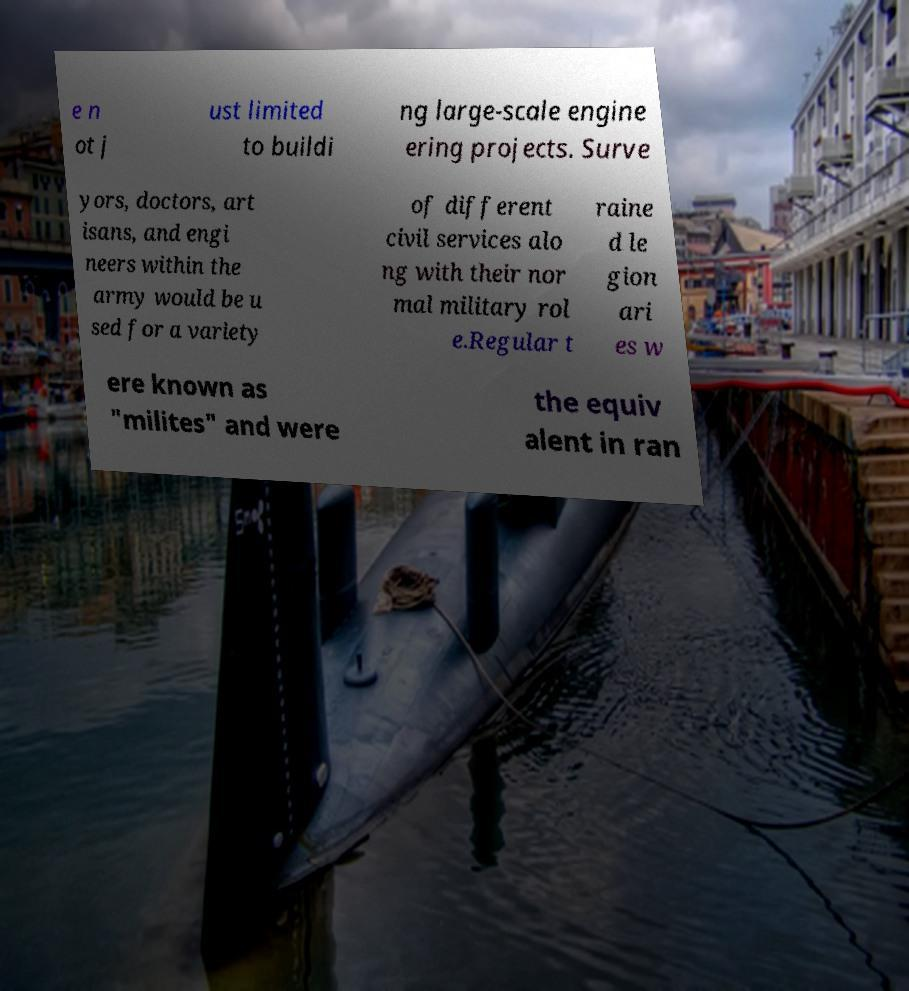For documentation purposes, I need the text within this image transcribed. Could you provide that? e n ot j ust limited to buildi ng large-scale engine ering projects. Surve yors, doctors, art isans, and engi neers within the army would be u sed for a variety of different civil services alo ng with their nor mal military rol e.Regular t raine d le gion ari es w ere known as "milites" and were the equiv alent in ran 